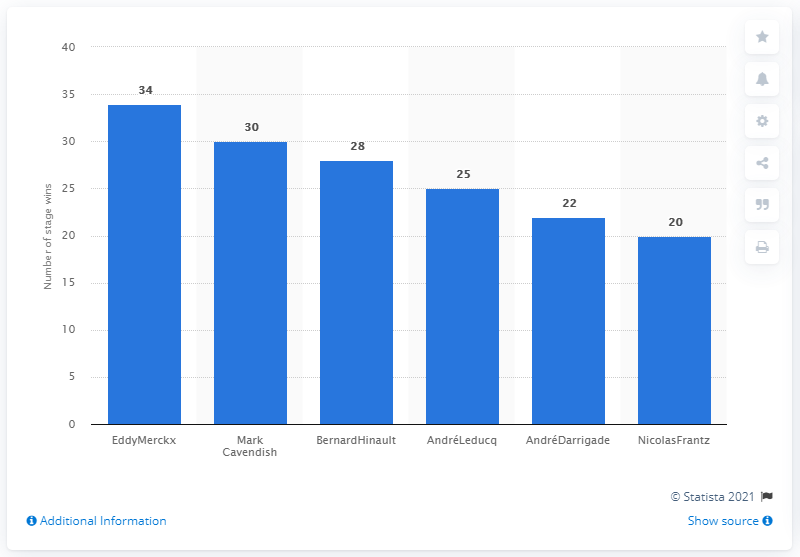List a handful of essential elements in this visual. Eddy Merckx, a renowned cyclist, won a total of 34 stages throughout his illustrious career. 